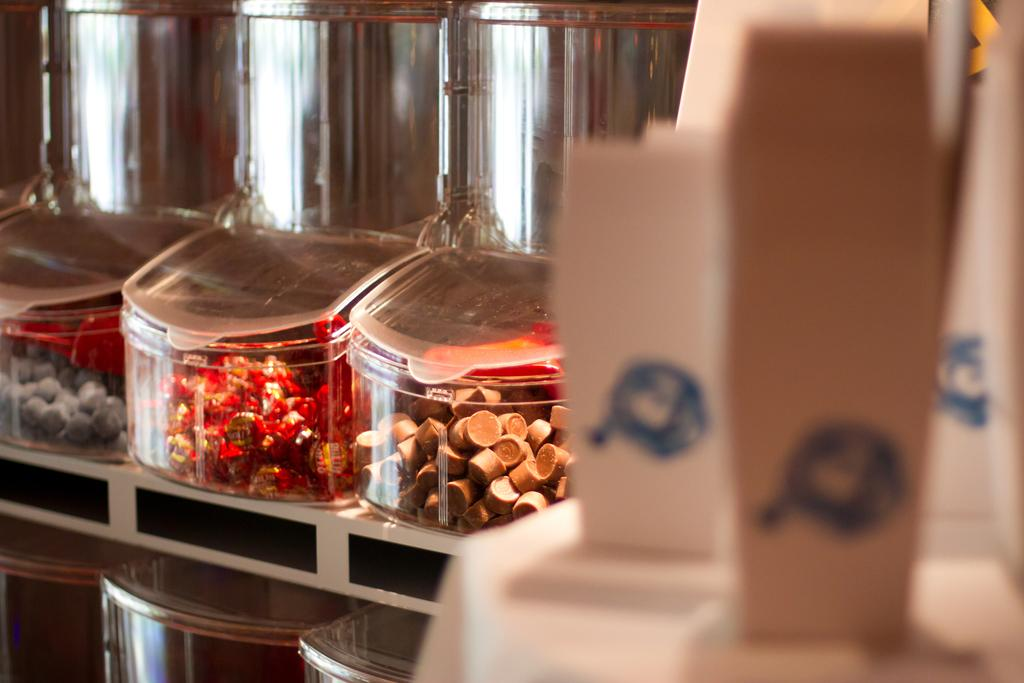What is inside the boxes in the image? There are objects in boxes in the image. Can you describe the object that is in front of the image? There is an object in front of the image, but its specific details cannot be discerned due to the blurred front side. How is the front side of the image affected? The front side of the image is blurred. How does the process of digestion affect the boys in the image? There are no boys present in the image, and therefore the process of digestion cannot be observed or discussed in relation to the image. 